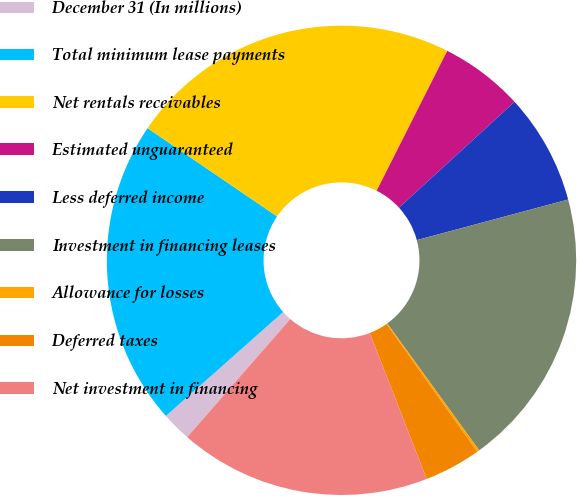<chart> <loc_0><loc_0><loc_500><loc_500><pie_chart><fcel>December 31 (In millions)<fcel>Total minimum lease payments<fcel>Net rentals receivables<fcel>Estimated unguaranteed<fcel>Less deferred income<fcel>Investment in financing leases<fcel>Allowance for losses<fcel>Deferred taxes<fcel>Net investment in financing<nl><fcel>2.04%<fcel>21.06%<fcel>22.92%<fcel>5.76%<fcel>7.63%<fcel>19.19%<fcel>0.17%<fcel>3.9%<fcel>17.33%<nl></chart> 